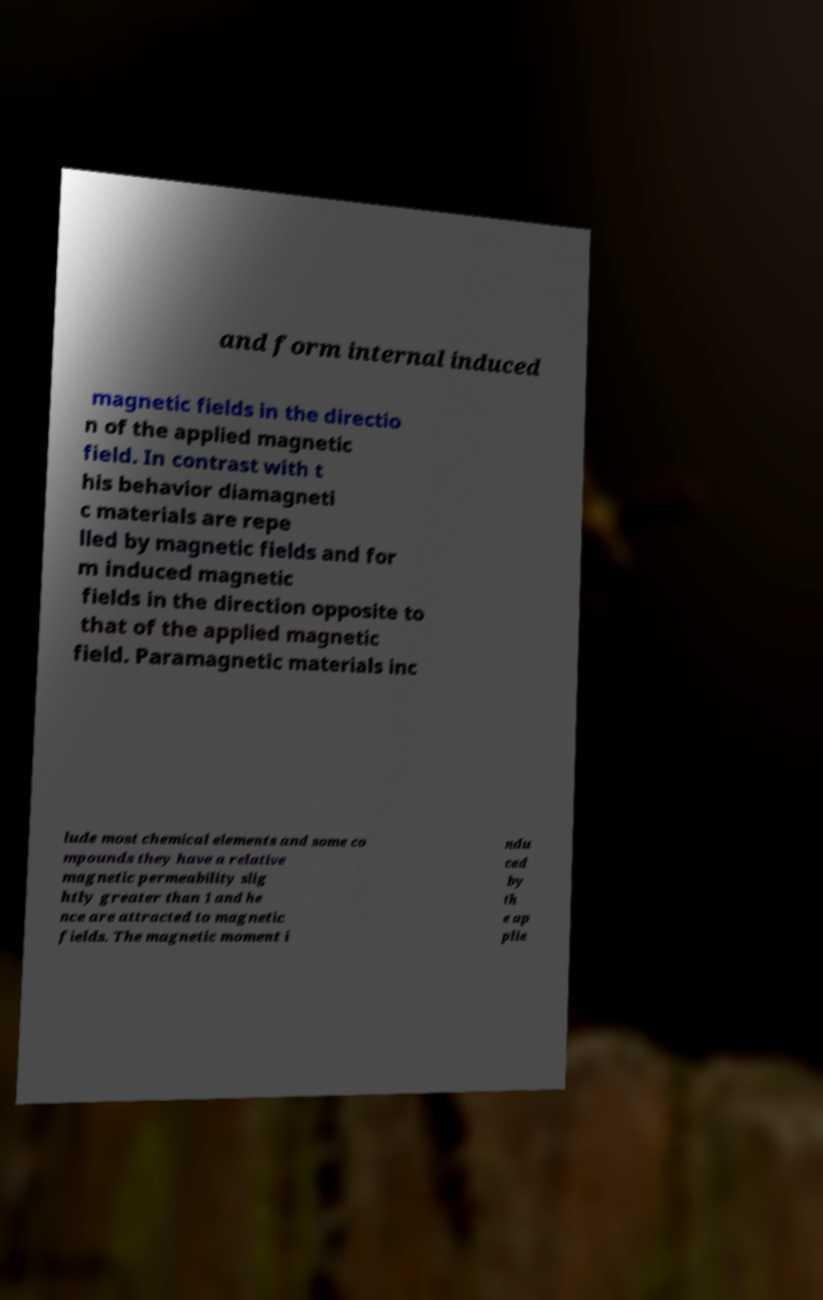Can you read and provide the text displayed in the image?This photo seems to have some interesting text. Can you extract and type it out for me? and form internal induced magnetic fields in the directio n of the applied magnetic field. In contrast with t his behavior diamagneti c materials are repe lled by magnetic fields and for m induced magnetic fields in the direction opposite to that of the applied magnetic field. Paramagnetic materials inc lude most chemical elements and some co mpounds they have a relative magnetic permeability slig htly greater than 1 and he nce are attracted to magnetic fields. The magnetic moment i ndu ced by th e ap plie 